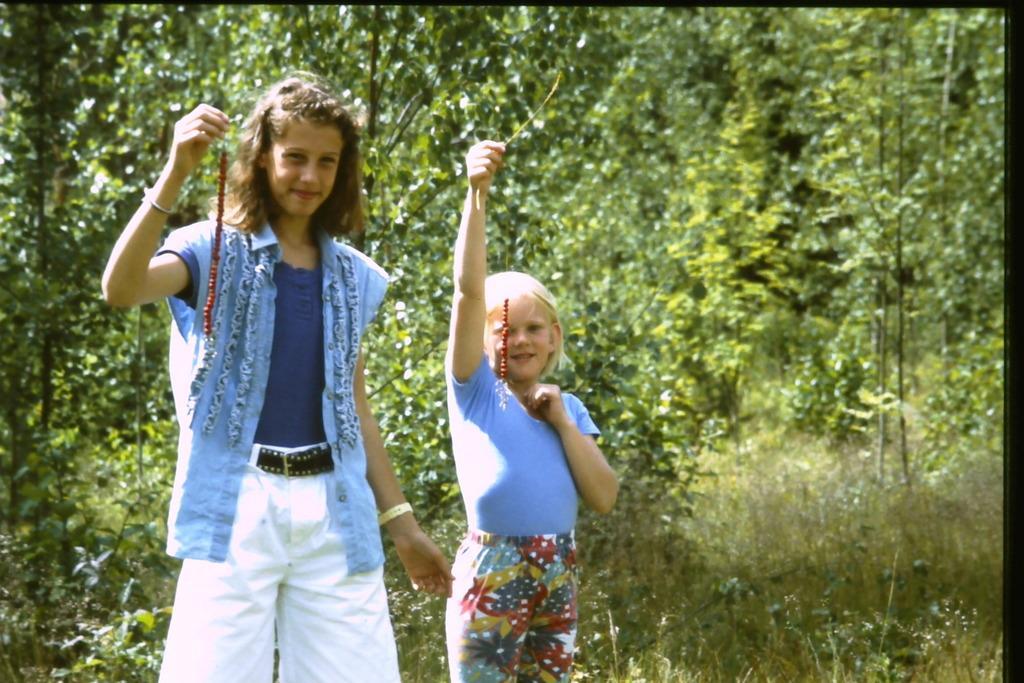How would you summarize this image in a sentence or two? In the center of the image there are two girls. In the background of the image there are trees. 